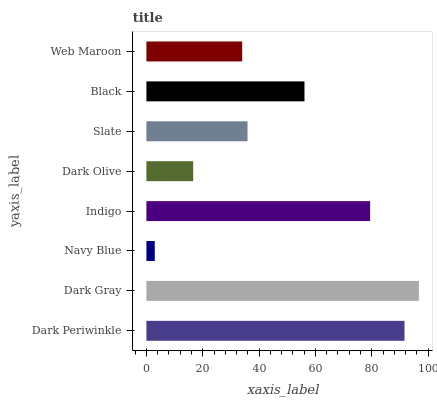Is Navy Blue the minimum?
Answer yes or no. Yes. Is Dark Gray the maximum?
Answer yes or no. Yes. Is Dark Gray the minimum?
Answer yes or no. No. Is Navy Blue the maximum?
Answer yes or no. No. Is Dark Gray greater than Navy Blue?
Answer yes or no. Yes. Is Navy Blue less than Dark Gray?
Answer yes or no. Yes. Is Navy Blue greater than Dark Gray?
Answer yes or no. No. Is Dark Gray less than Navy Blue?
Answer yes or no. No. Is Black the high median?
Answer yes or no. Yes. Is Slate the low median?
Answer yes or no. Yes. Is Indigo the high median?
Answer yes or no. No. Is Dark Gray the low median?
Answer yes or no. No. 